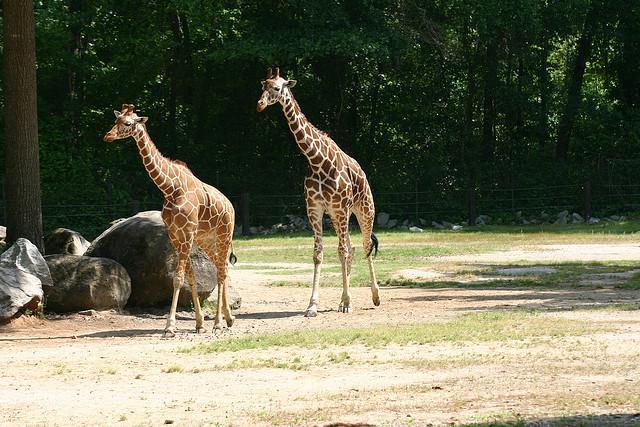How many giraffes are there?
Give a very brief answer. 2. How many giraffes are visible?
Give a very brief answer. 2. 